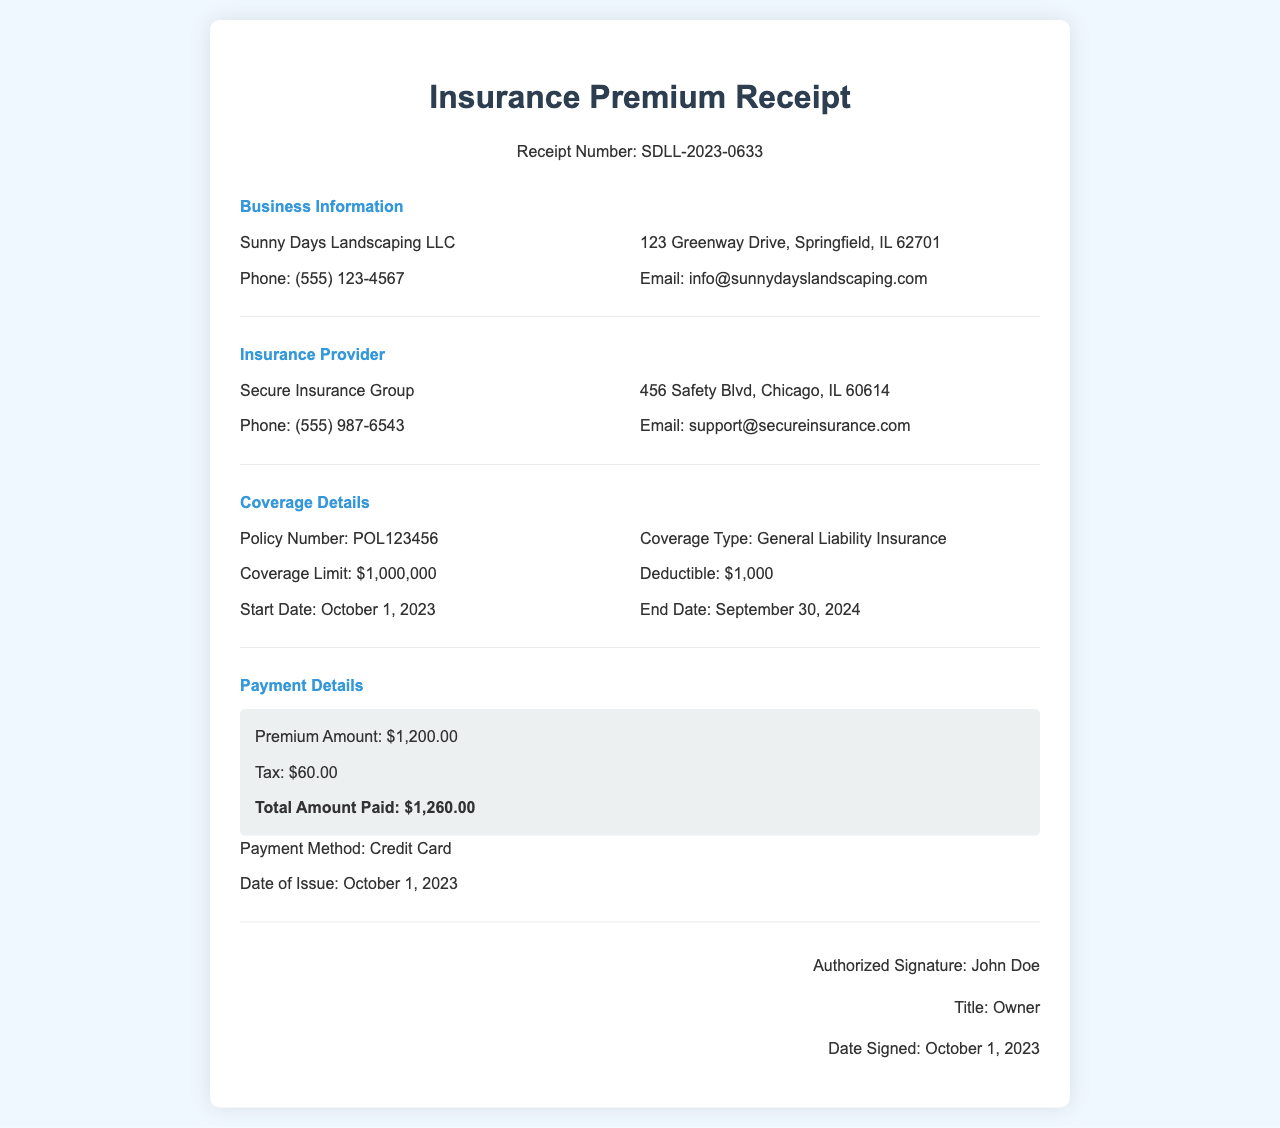What is the business name? The business name is listed at the top of the document under Business Information as "Sunny Days Landscaping LLC."
Answer: Sunny Days Landscaping LLC What is the total amount paid? The total amount paid is outlined in the Payment Details section, which includes the Premium Amount and Tax. The Total Amount Paid is $1,260.00.
Answer: $1,260.00 Who is the insurance provider? The insurance provider is specified under the Insurance Provider section. The name of the provider is "Secure Insurance Group."
Answer: Secure Insurance Group What is the policy number? The policy number is mentioned in the Coverage Details section as "POL123456."
Answer: POL123456 When does the coverage start? The start date of the coverage is stated in the Coverage Details section as "October 1, 2023."
Answer: October 1, 2023 How much is the coverage limit? The coverage limit is provided in the Coverage Details section and is stated as "$1,000,000."
Answer: $1,000,000 What payment method was used? The payment method is indicated in the Payment Details section as "Credit Card."
Answer: Credit Card What is the deductible amount? The deductible amount is included in the Coverage Details section and is indicated as "$1,000."
Answer: $1,000 Who signed the receipt? The authorized signer is mentioned in the signature section with the name "John Doe."
Answer: John Doe 